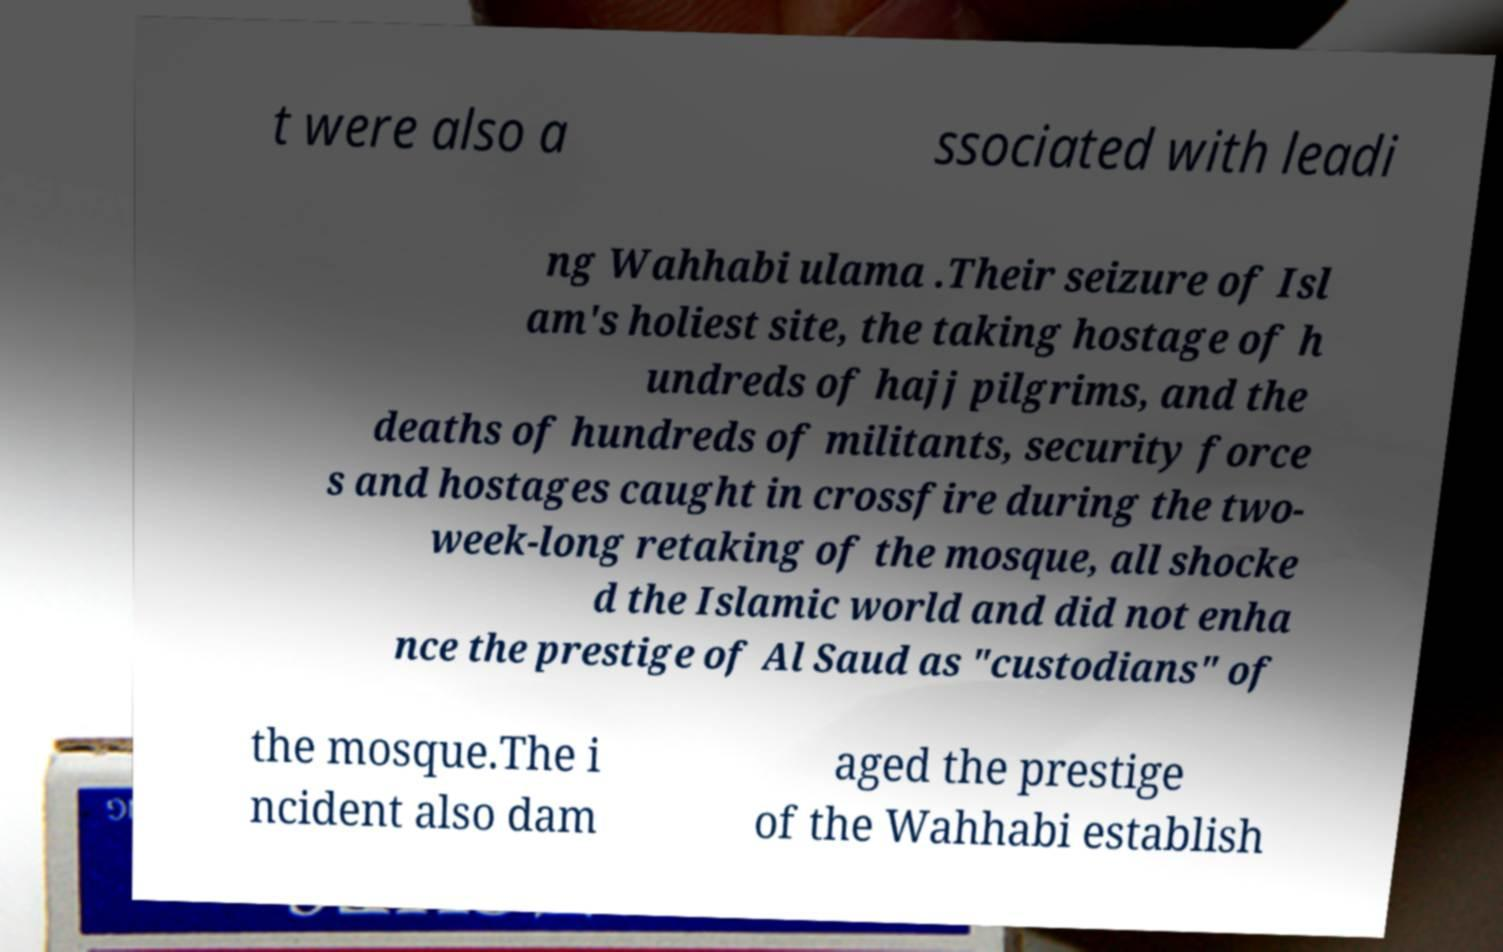Please identify and transcribe the text found in this image. t were also a ssociated with leadi ng Wahhabi ulama .Their seizure of Isl am's holiest site, the taking hostage of h undreds of hajj pilgrims, and the deaths of hundreds of militants, security force s and hostages caught in crossfire during the two- week-long retaking of the mosque, all shocke d the Islamic world and did not enha nce the prestige of Al Saud as "custodians" of the mosque.The i ncident also dam aged the prestige of the Wahhabi establish 